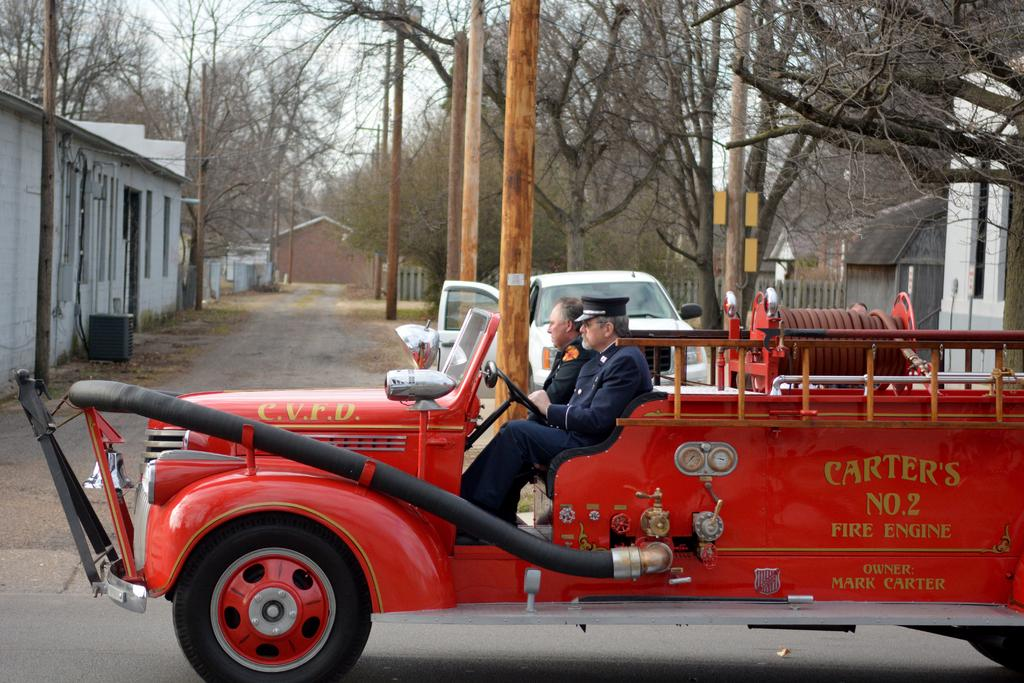How many people are in the vehicle in the image? There are two persons sitting in the vehicle. What else can be seen on the road in the image? There are vehicles on the road. What type of structure is present in the image? There is a shed in the image. What type of vegetation is visible in the image? There are trees in the image. What is visible in the background of the image? The sky is visible in the image. What type of building is present in the image? There is a house in the image. How many cattle are grazing in the image? There are no cattle present in the image. What type of bird can be seen flying in the image? There are no birds visible in the image. 